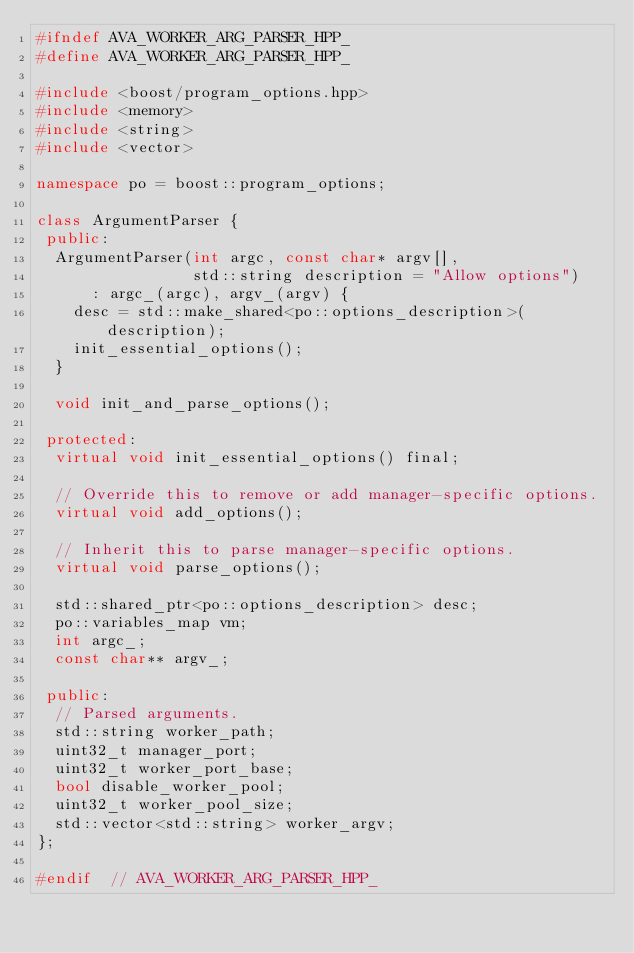Convert code to text. <code><loc_0><loc_0><loc_500><loc_500><_C++_>#ifndef AVA_WORKER_ARG_PARSER_HPP_
#define AVA_WORKER_ARG_PARSER_HPP_

#include <boost/program_options.hpp>
#include <memory>
#include <string>
#include <vector>

namespace po = boost::program_options;

class ArgumentParser {
 public:
  ArgumentParser(int argc, const char* argv[],
                 std::string description = "Allow options")
      : argc_(argc), argv_(argv) {
    desc = std::make_shared<po::options_description>(description);
    init_essential_options();
  }

  void init_and_parse_options();

 protected:
  virtual void init_essential_options() final;

  // Override this to remove or add manager-specific options.
  virtual void add_options();

  // Inherit this to parse manager-specific options.
  virtual void parse_options();

  std::shared_ptr<po::options_description> desc;
  po::variables_map vm;
  int argc_;
  const char** argv_;

 public:
  // Parsed arguments.
  std::string worker_path;
  uint32_t manager_port;
  uint32_t worker_port_base;
  bool disable_worker_pool;
  uint32_t worker_pool_size;
  std::vector<std::string> worker_argv;
};

#endif  // AVA_WORKER_ARG_PARSER_HPP_
</code> 